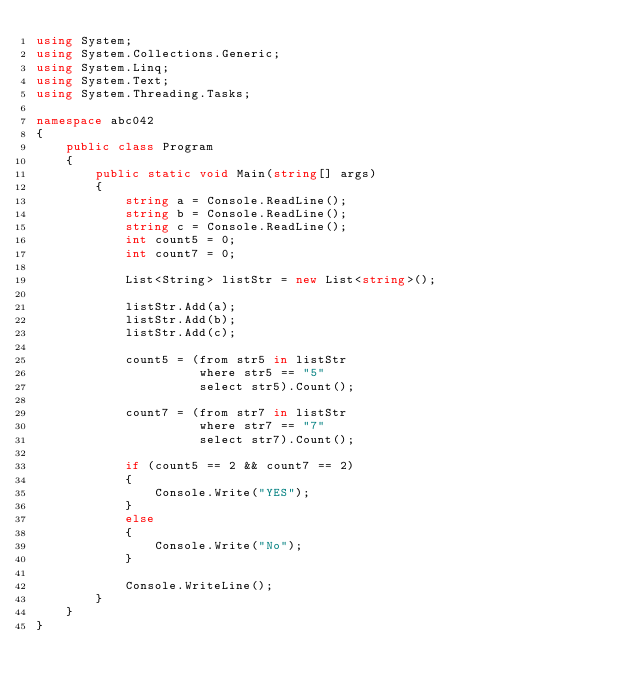Convert code to text. <code><loc_0><loc_0><loc_500><loc_500><_C#_>using System;
using System.Collections.Generic;
using System.Linq;
using System.Text;
using System.Threading.Tasks;

namespace abc042
{
    public class Program
    {
        public static void Main(string[] args)
        {
            string a = Console.ReadLine();
            string b = Console.ReadLine();
            string c = Console.ReadLine();
            int count5 = 0;
            int count7 = 0;

            List<String> listStr = new List<string>();

            listStr.Add(a);
            listStr.Add(b);
            listStr.Add(c);

            count5 = (from str5 in listStr
                      where str5 == "5"
                      select str5).Count();

            count7 = (from str7 in listStr
                      where str7 == "7"
                      select str7).Count();

            if (count5 == 2 && count7 == 2)
            {
                Console.Write("YES");
            }
            else
            {
                Console.Write("No");
            }

            Console.WriteLine();
        }
    }
}
</code> 